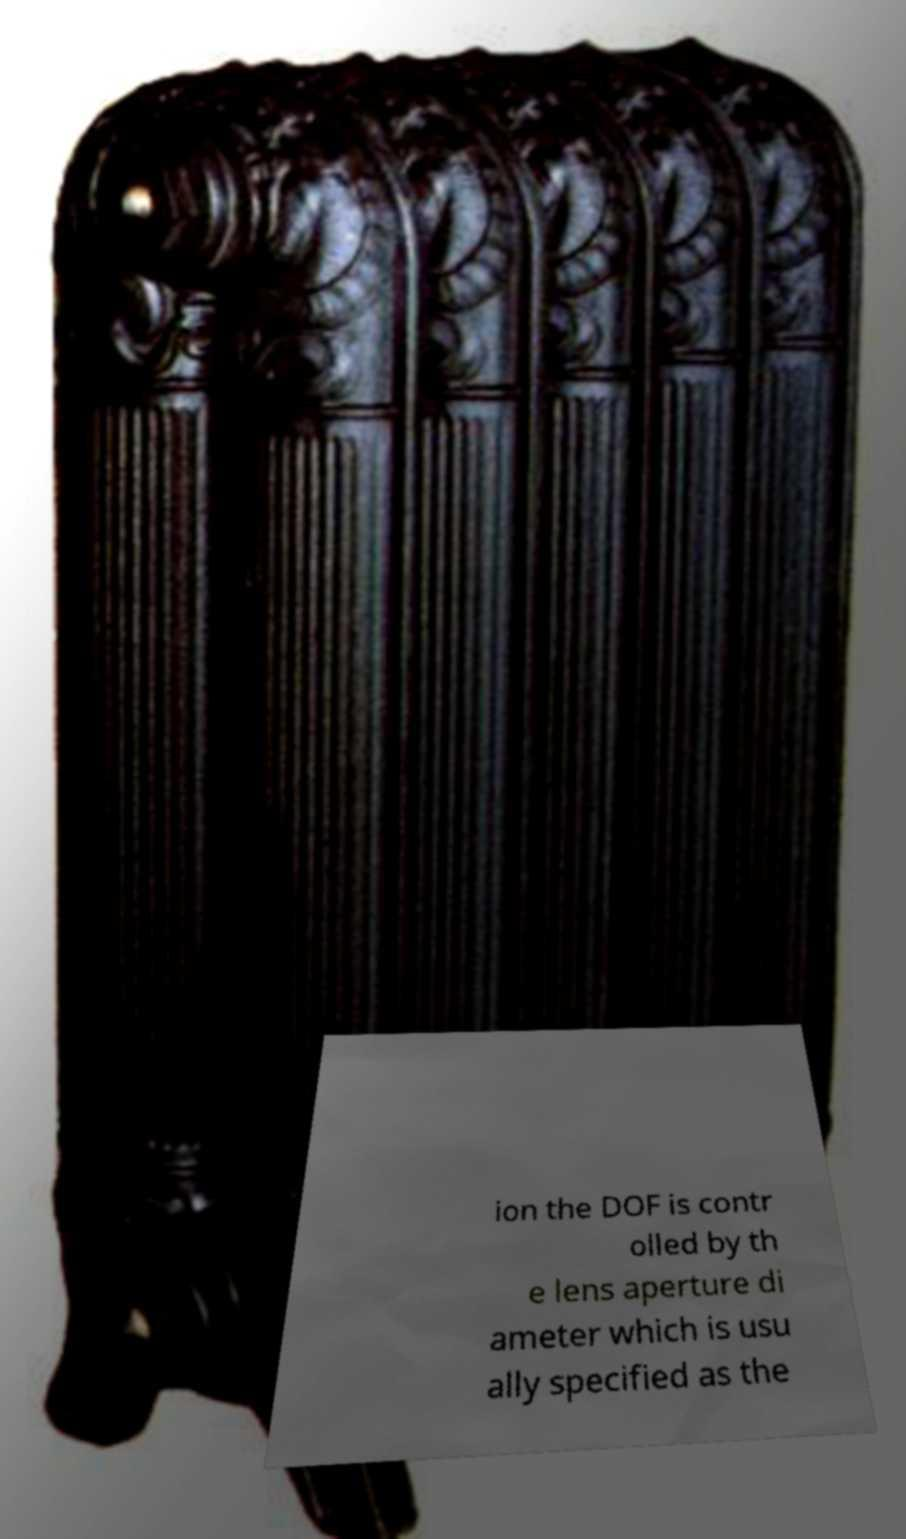Can you read and provide the text displayed in the image?This photo seems to have some interesting text. Can you extract and type it out for me? ion the DOF is contr olled by th e lens aperture di ameter which is usu ally specified as the 